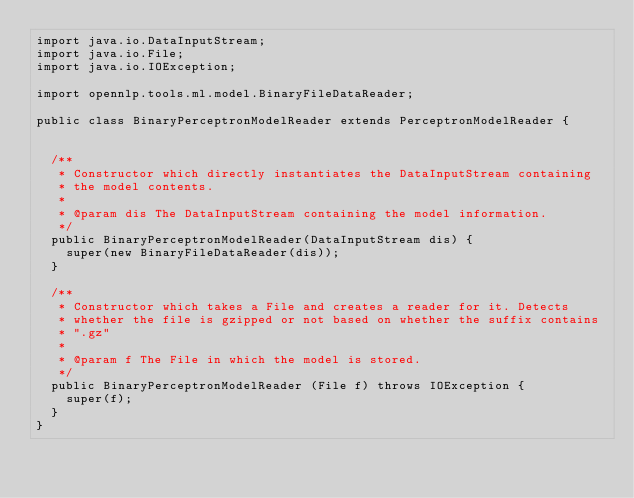Convert code to text. <code><loc_0><loc_0><loc_500><loc_500><_Java_>import java.io.DataInputStream;
import java.io.File;
import java.io.IOException;

import opennlp.tools.ml.model.BinaryFileDataReader;

public class BinaryPerceptronModelReader extends PerceptronModelReader {


  /**
   * Constructor which directly instantiates the DataInputStream containing
   * the model contents.
   *
   * @param dis The DataInputStream containing the model information.
   */
  public BinaryPerceptronModelReader(DataInputStream dis) {
    super(new BinaryFileDataReader(dis));
  }

  /**
   * Constructor which takes a File and creates a reader for it. Detects
   * whether the file is gzipped or not based on whether the suffix contains
   * ".gz"
   *
   * @param f The File in which the model is stored.
   */
  public BinaryPerceptronModelReader (File f) throws IOException {
    super(f);
  }
}
</code> 